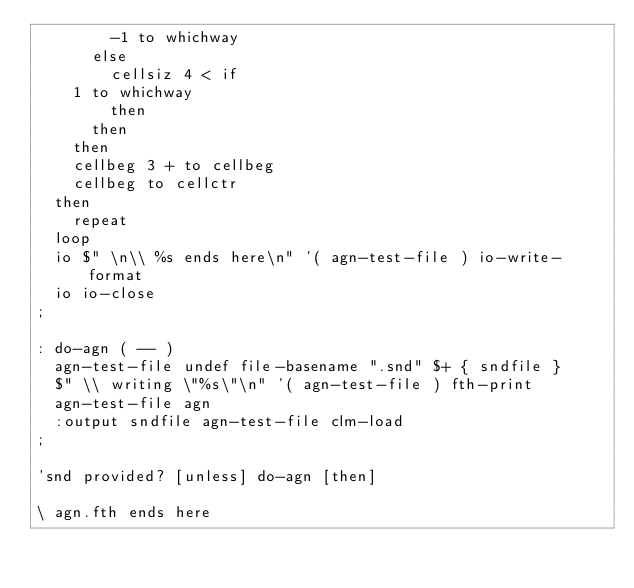Convert code to text. <code><loc_0><loc_0><loc_500><loc_500><_Forth_>	      -1 to whichway
	    else
	      cellsiz 4 < if
		1 to whichway
	      then
	    then
	  then
	  cellbeg 3 + to cellbeg
	  cellbeg to cellctr
	then
    repeat
  loop
  io $" \n\\ %s ends here\n" '( agn-test-file ) io-write-format
  io io-close
;

: do-agn ( -- )
  agn-test-file undef file-basename ".snd" $+ { sndfile }
  $" \\ writing \"%s\"\n" '( agn-test-file ) fth-print
  agn-test-file agn
  :output sndfile agn-test-file clm-load
;

'snd provided? [unless] do-agn [then]

\ agn.fth ends here
</code> 